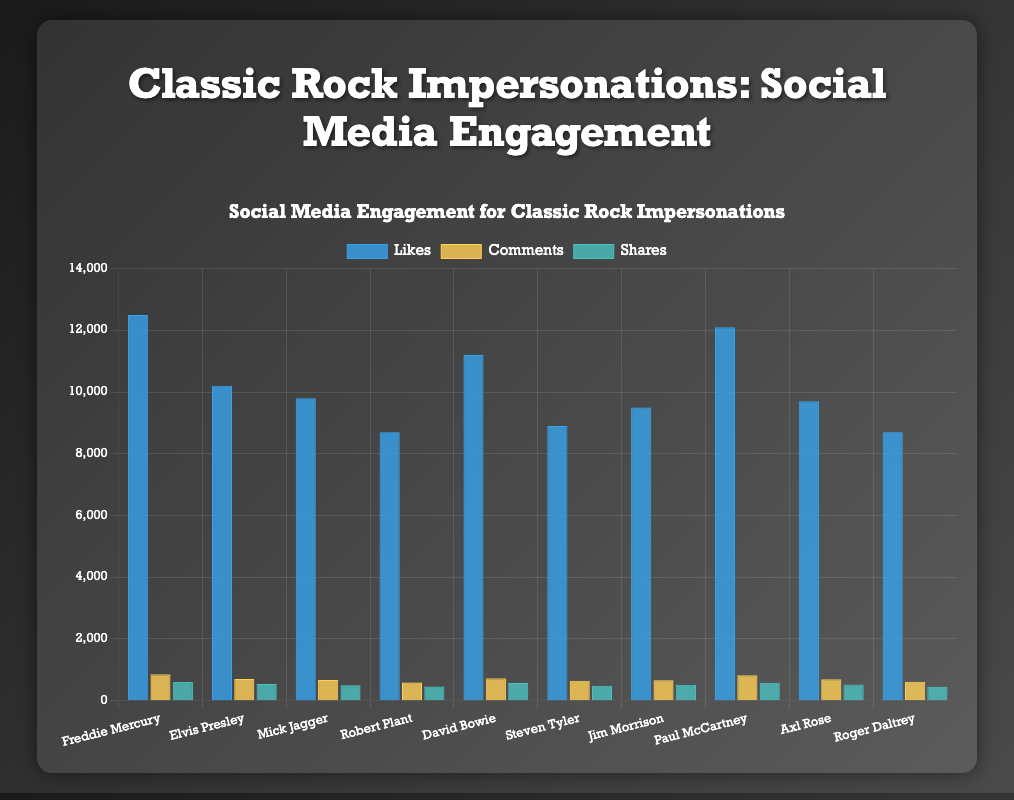Which impersonation received the highest number of likes? Refer to the 'Likes' bars in the chart and find the one that extends the most to the right, which represents Freddie Mercury with 12500 likes.
Answer: Freddie Mercury How many more likes did Paul McCartney get compared to Mick Jagger? Paul McCartney received 12100 likes and Mick Jagger received 9800 likes. Subtract 9800 from 12100 to get the difference.
Answer: 2300 Which impersonation had the least number of shares? Look at the 'Shares' bars in the chart and identify the lowest one, which is for Roger Daltrey with 450 shares.
Answer: Roger Daltrey What is the total number of comments received by David Bowie and Elvis Presley together? David Bowie received 720 comments and Elvis Presley received 700 comments. Add these two values together to get the total.
Answer: 1420 Among all the impersonations, which one has the second highest number of likes? The highest number of likes is 12500 for Freddie Mercury. The second highest is 12100 for Paul McCartney.
Answer: Paul McCartney Which impersonation received the highest number of combined social media engagements (likes, comments, and shares)? Sum up the likes, comments, and shares for each impersonation, and the one with the highest total is Paul McCartney (12100 + 820 + 580 = 13500).
Answer: Paul McCartney How do the likes for Axl Rose compare with those for Jim Morrison? Axl Rose received 9700 likes whereas Jim Morrison received 9500 likes. Compare these values to determine that Axl Rose had more likes.
Answer: Axl Rose had more likes Which impersonation has the closest numbers of likes and comments? Calculate the difference between likes and comments for each impersonation and find the smallest difference. Paul McCartney has 12100 likes and 820 comments, resulting in a difference of 11280, which is the smallest.
Answer: Paul McCartney What is the average number of shares across all impersonations? Calculate the total shares by adding all shares: 600 + 540 + 500 + 460 + 570 + 480 + 510 + 580 + 520 + 450 = 5210. Divide by the number of impersonations (10) to find the average.
Answer: 521 